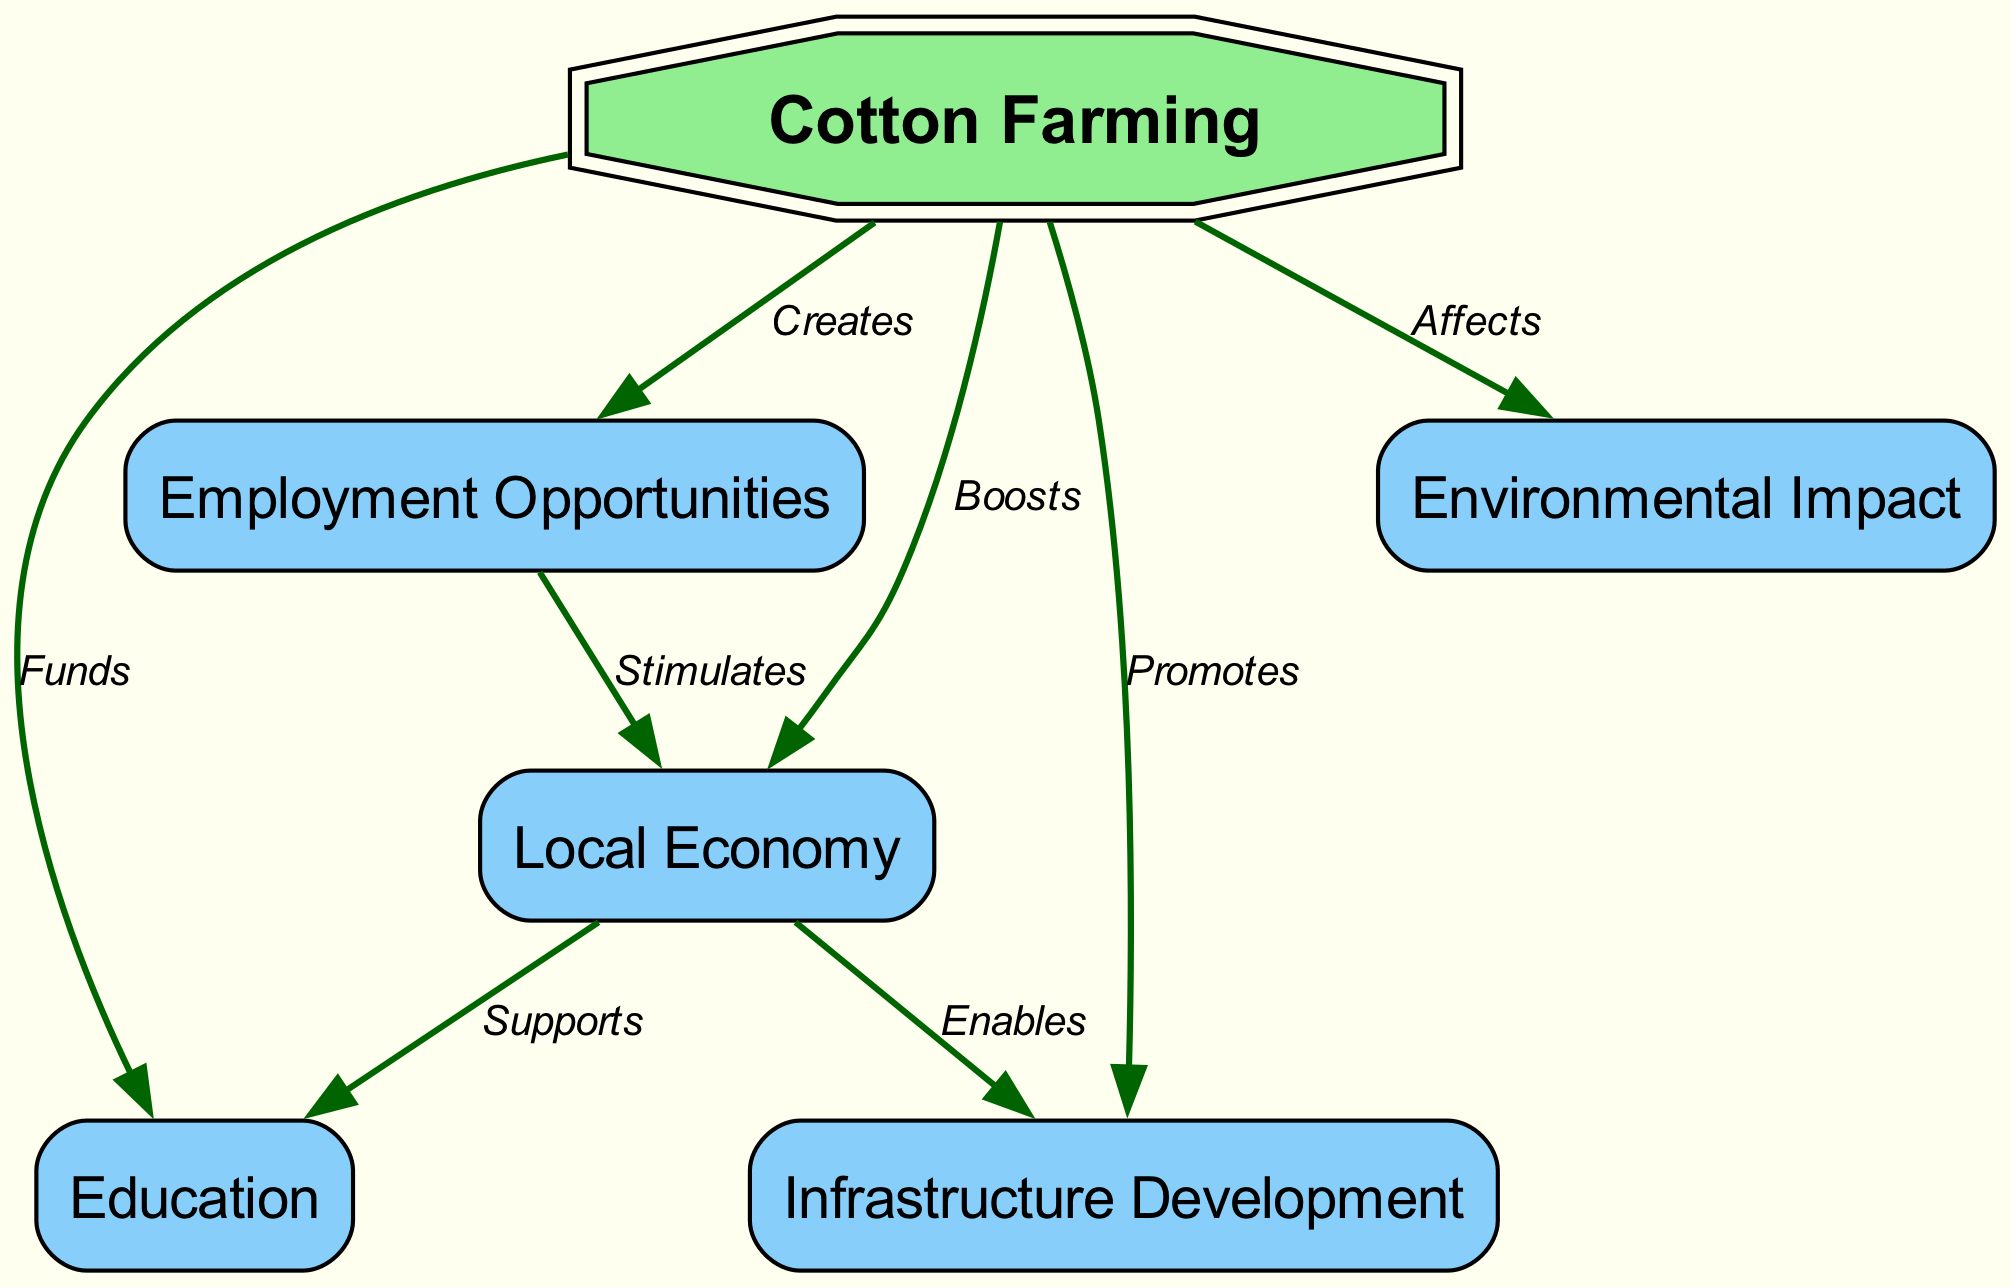What is the total number of nodes in the diagram? The diagram lists six different nodes related to the socioeconomic impact of cotton farming, including "Cotton Farming," "Employment Opportunities," "Local Economy," "Education," "Infrastructure Development," and "Environmental Impact."
Answer: 6 What does cotton farming create in rural communities? According to the diagram, the edge from "Cotton Farming" to "Employment Opportunities" is labeled "Creates," indicating that cotton farming leads to job creation in these communities.
Answer: Employment Opportunities What relationship exists between the local economy and education? The diagram shows that the "Local Economy" supports "Education," which indicates a positive relationship where a stronger local economy can contribute to better education outcomes in the community.
Answer: Supports How many edges are there in the diagram? By counting the connections between the nodes, the diagram contains a total of eight edges showing the relationships between different socioeconomic factors and cotton farming.
Answer: 8 Which factors does cotton farming promote in rural communities? The diagram indicates that cotton farming promotes both "Infrastructure Development" and "Employment Opportunities," suggesting that farming activities lead to improvements in community infrastructure and job creation.
Answer: Infrastructure Development, Employment Opportunities What is the effect of cotton farming on environmental impact? The diagram denotes that cotton farming "Affects" the "Environmental Impact," meaning that there is a notable relationship where farming practices can lead to various environmental changes, whether positive or negative.
Answer: Affects Which node is identified as a double octagon? In the diagram, "Cotton Farming" is specifically identified with a double octagon shape, indicating its primary significance in the socioeconomic context represented.
Answer: Cotton Farming How does the local economy stimulate employment opportunities? The diagram illustrates a connection where the "Local Economy" stimulates "Employment Opportunities," suggesting that a vibrant economy helps to create jobs within the community, showing a reciprocal relationship.
Answer: Stimulates What does the local economy enable regarding infrastructure? The diagram indicates that the "Local Economy" enables "Infrastructure Development," meaning that a thriving economy can support and fund projects to improve local infrastructure.
Answer: Enables 